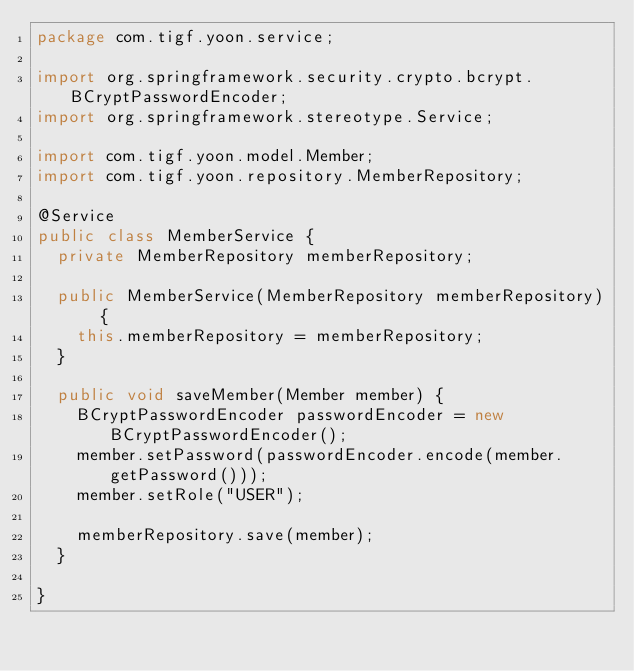Convert code to text. <code><loc_0><loc_0><loc_500><loc_500><_Java_>package com.tigf.yoon.service;

import org.springframework.security.crypto.bcrypt.BCryptPasswordEncoder;
import org.springframework.stereotype.Service;

import com.tigf.yoon.model.Member;
import com.tigf.yoon.repository.MemberRepository;

@Service
public class MemberService {
	private MemberRepository memberRepository;

	public MemberService(MemberRepository memberRepository) {
		this.memberRepository = memberRepository;
	}

	public void saveMember(Member member) {
		BCryptPasswordEncoder passwordEncoder = new BCryptPasswordEncoder();
		member.setPassword(passwordEncoder.encode(member.getPassword()));
		member.setRole("USER");
		
		memberRepository.save(member);
	}
	
}
</code> 